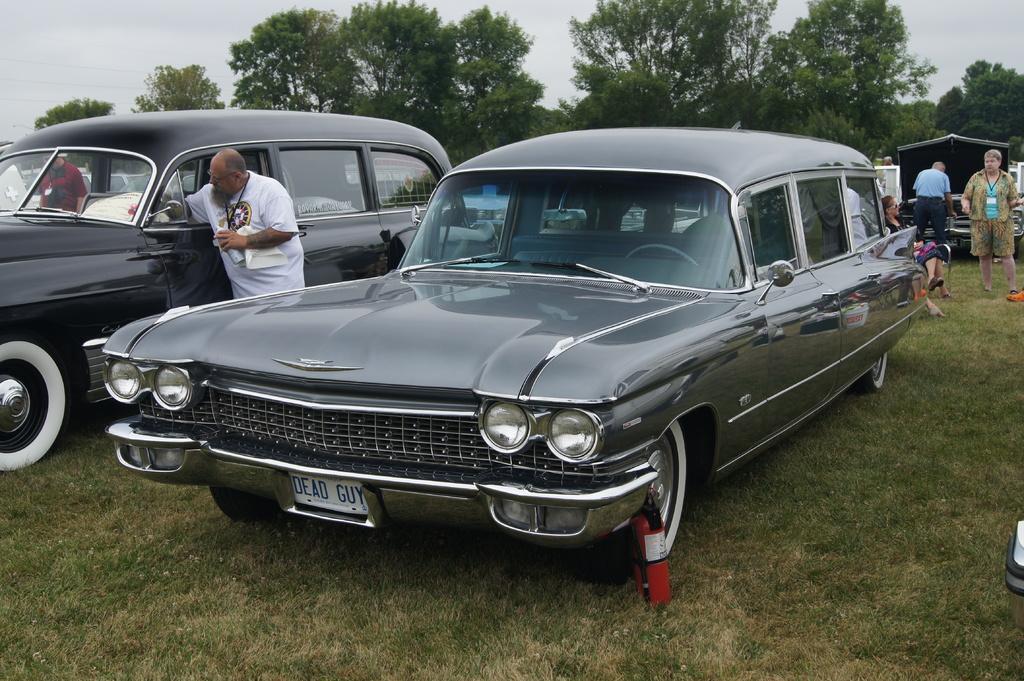Please provide a concise description of this image. In this image we can see two cars which are of different colors parked and at the background of the image there are some persons standing, sitting there are some trees and clear sky. 